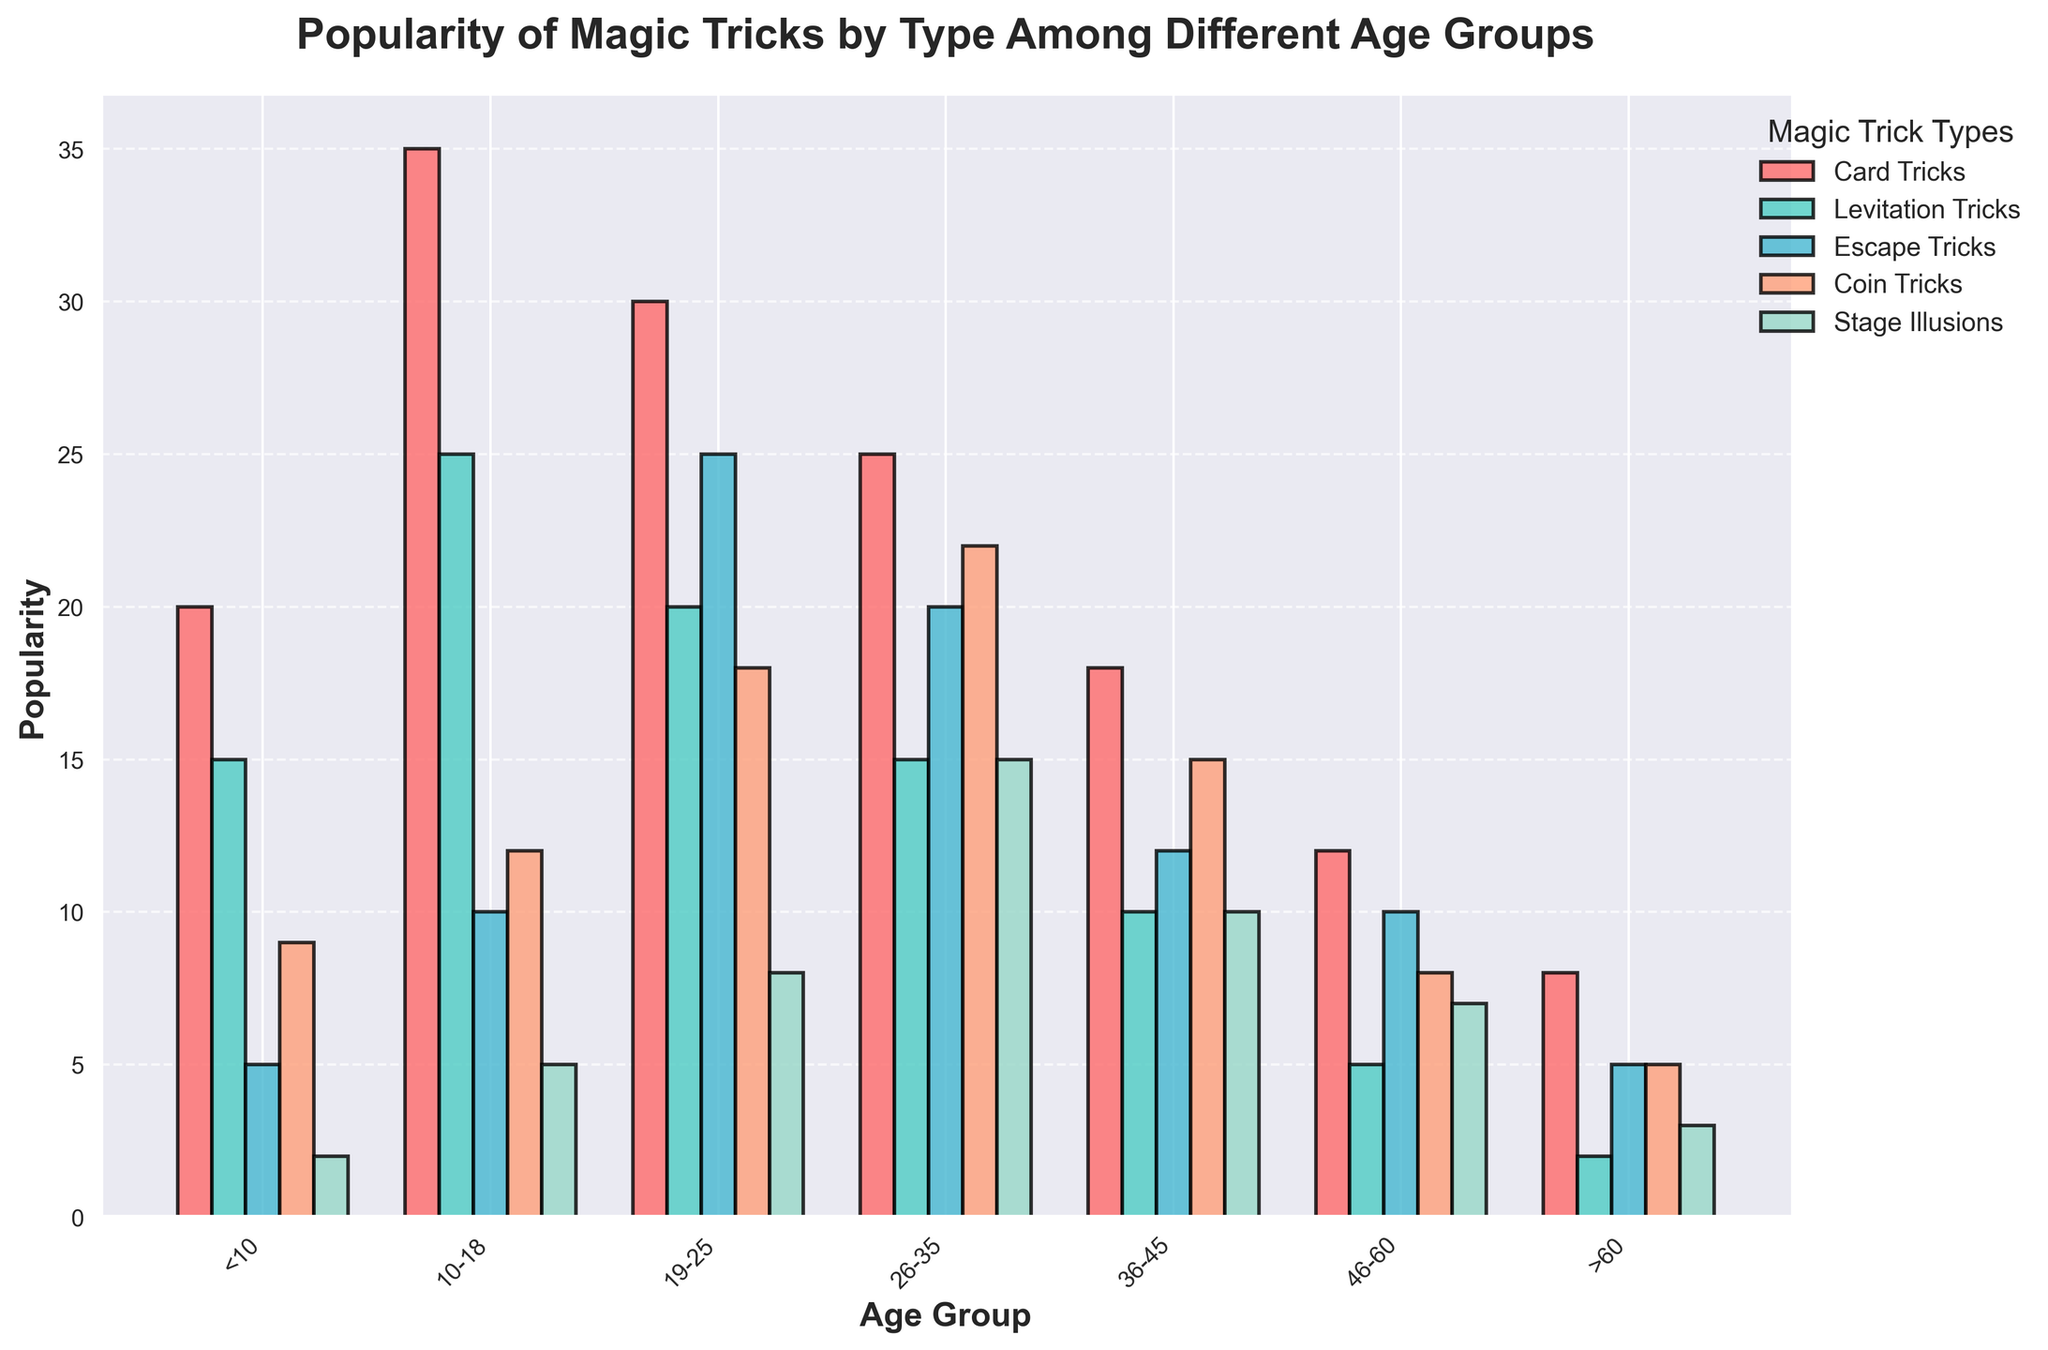What's the title of the figure? The title is usually displayed at the top of the figure in a larger, bold font.
Answer: Popularity of Magic Tricks by Type Among Different Age Groups What is the most popular type of magic trick among the age group 10-18? Look at the bars correspond to each magic trick type for the 10-18 age group and find the tallest bar.
Answer: Card Tricks Which age group has the least interest in Stage Illusions? Find the shortest bar for Stage Illusions (green) across all age groups.
Answer: >60 How many age groups are presented in the figure? Count the number of distinct age groups on the x-axis.
Answer: 7 For the 26-35 age group, what is the combined popularity of Card Tricks and Stage Illusions? Find the heights of the bars for Card Tricks and Stage Illusions for the 26-35 age group and sum them up. The height of Card Tricks is 25, and for Stage Illusions, it is 15. So, the total is 25 + 15 = 40.
Answer: 40 Which magic trick type shows a significant decrease in popularity with increasing age? Track the bar heights for each magic trick type by following the sequence of age groups and identify which type shows an evident decline.
Answer: Card Tricks In the 19-25 age group, by how much is the popularity of Escape Tricks greater than Levitation Tricks? Measure the height difference between the two bars (Escape Tricks and Levitation Tricks) for the 19-25 age group: Escape Tricks is 25 and Levitation Tricks is 20. The difference is 25 - 20 = 5.
Answer: 5 What is the average popularity of Coin Tricks across all age groups? Sum the heights of all bars for Coin Tricks across each age group and divide by the number of age groups (7). The values are 9, 12, 18, 22, 15, 8, 5. The sum is 9+12+18+22+15+8+5 = 89, and the average is 89/7 ≈ 12.71
Answer: 12.71 Which age group shows the highest interest in Levitation Tricks? Identify the highest bar for Levitation Tricks across all age groups.
Answer: 10-18 How does the popularity of magic tricks change from age group 19-25 to 26-35 for Escape Tricks? Compare the heights of the bars for Escape Tricks between the 19-25 and 26-35 age groups. The height for 19-25 is 25 and for 26-35 is 20. The popularity decreases by 5.
Answer: Decreases by 5 